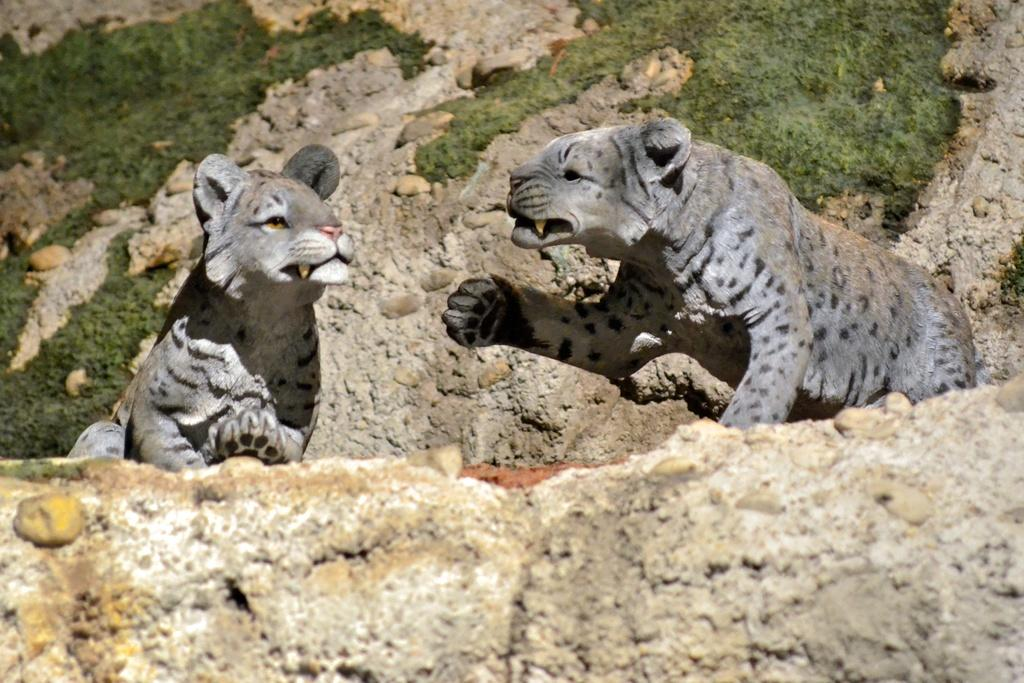What types of objects are present in the image? There are two animal statues in the image. What is the horse's interest in the board game in the image? There is no horse or board game present in the image; it only features two animal statues. 